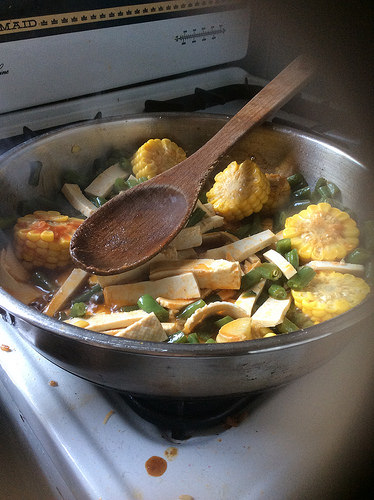<image>
Can you confirm if the vegtables is on the pan? Yes. Looking at the image, I can see the vegtables is positioned on top of the pan, with the pan providing support. 